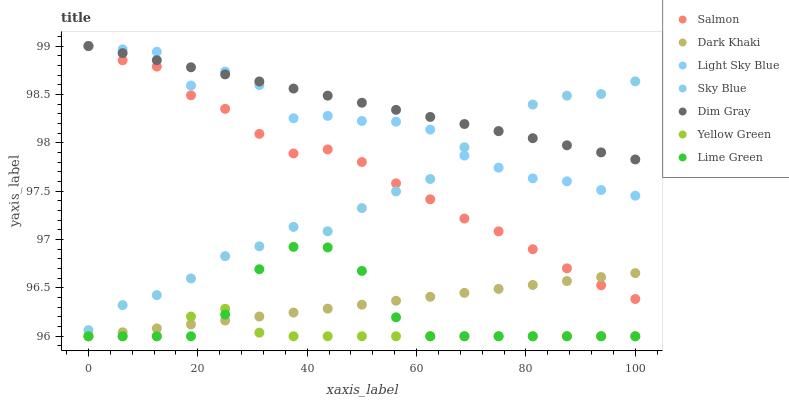Does Yellow Green have the minimum area under the curve?
Answer yes or no. Yes. Does Dim Gray have the maximum area under the curve?
Answer yes or no. Yes. Does Salmon have the minimum area under the curve?
Answer yes or no. No. Does Salmon have the maximum area under the curve?
Answer yes or no. No. Is Dark Khaki the smoothest?
Answer yes or no. Yes. Is Light Sky Blue the roughest?
Answer yes or no. Yes. Is Yellow Green the smoothest?
Answer yes or no. No. Is Yellow Green the roughest?
Answer yes or no. No. Does Yellow Green have the lowest value?
Answer yes or no. Yes. Does Salmon have the lowest value?
Answer yes or no. No. Does Light Sky Blue have the highest value?
Answer yes or no. Yes. Does Salmon have the highest value?
Answer yes or no. No. Is Salmon less than Light Sky Blue?
Answer yes or no. Yes. Is Salmon greater than Yellow Green?
Answer yes or no. Yes. Does Dim Gray intersect Sky Blue?
Answer yes or no. Yes. Is Dim Gray less than Sky Blue?
Answer yes or no. No. Is Dim Gray greater than Sky Blue?
Answer yes or no. No. Does Salmon intersect Light Sky Blue?
Answer yes or no. No. 